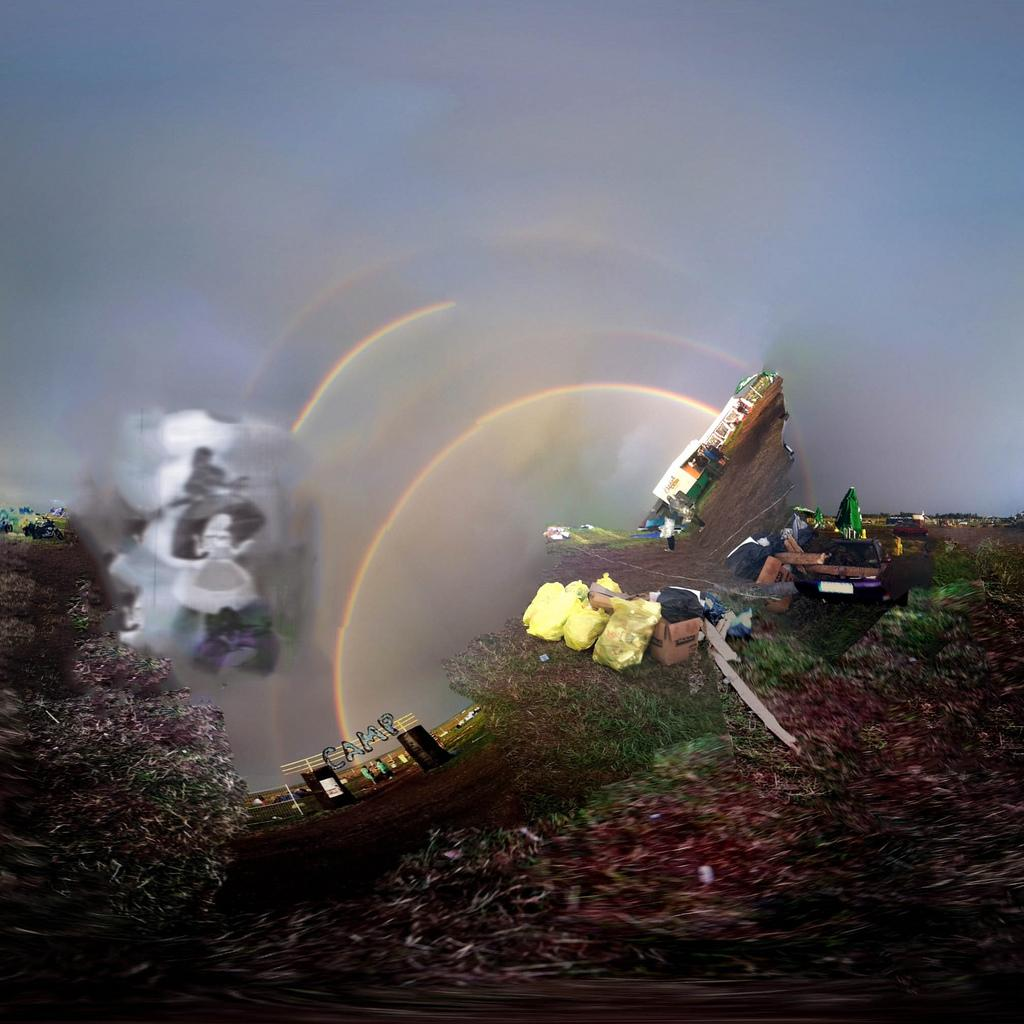What natural phenomenon can be seen in the image? There is a rainbow in the image. What type of setting is depicted in the image? There is a camp in the image. What type of vegetation is present in the image? There are plants and grass in the image. What other materials can be seen in the image? There are other materials in the image. What type of holiday is being celebrated in the image? There is no indication of a holiday being celebrated in the image. How does the jar adjust to the changing weather conditions in the image? There is no jar present in the image. 